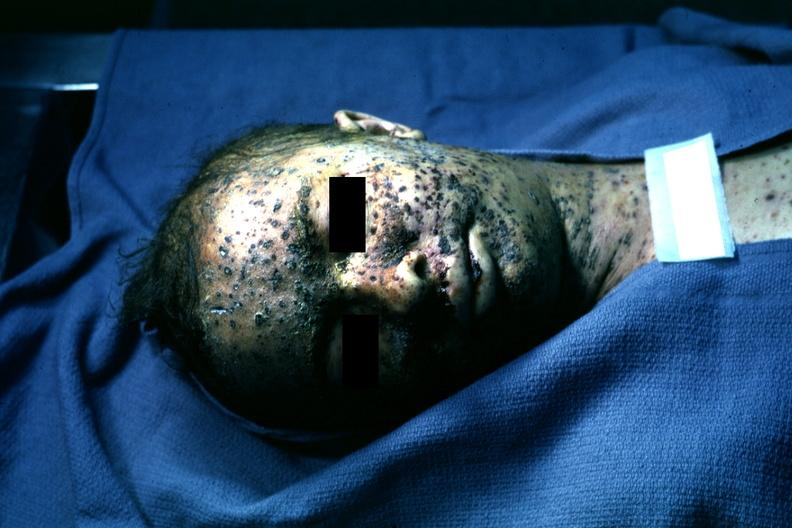what is present?
Answer the question using a single word or phrase. Herpes zoster 